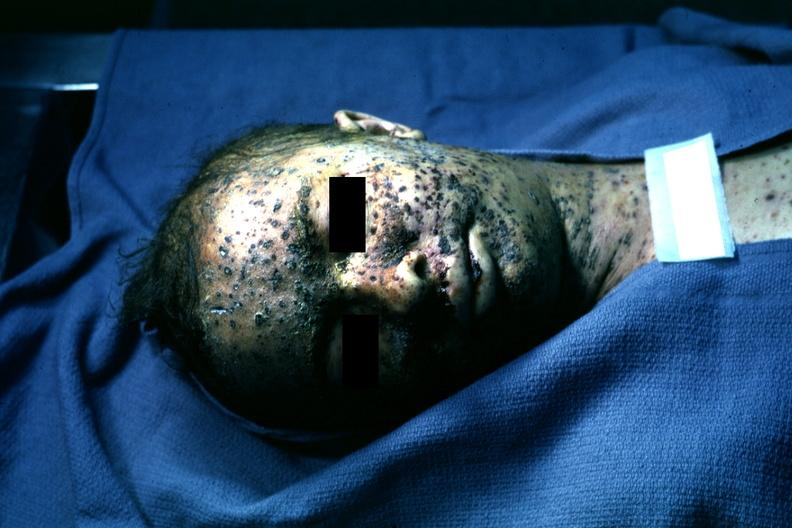what is present?
Answer the question using a single word or phrase. Herpes zoster 